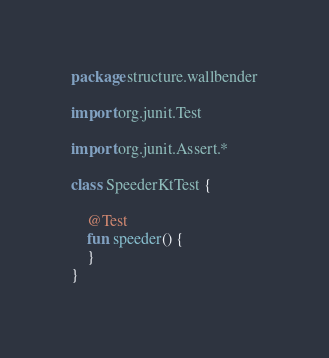Convert code to text. <code><loc_0><loc_0><loc_500><loc_500><_Kotlin_>package structure.wallbender

import org.junit.Test

import org.junit.Assert.*

class SpeederKtTest {

    @Test
    fun speeder() {
    }
}</code> 